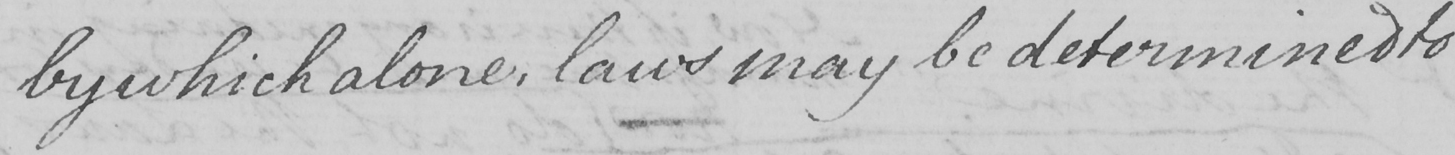Please provide the text content of this handwritten line. by which alone , laws may be determined to 